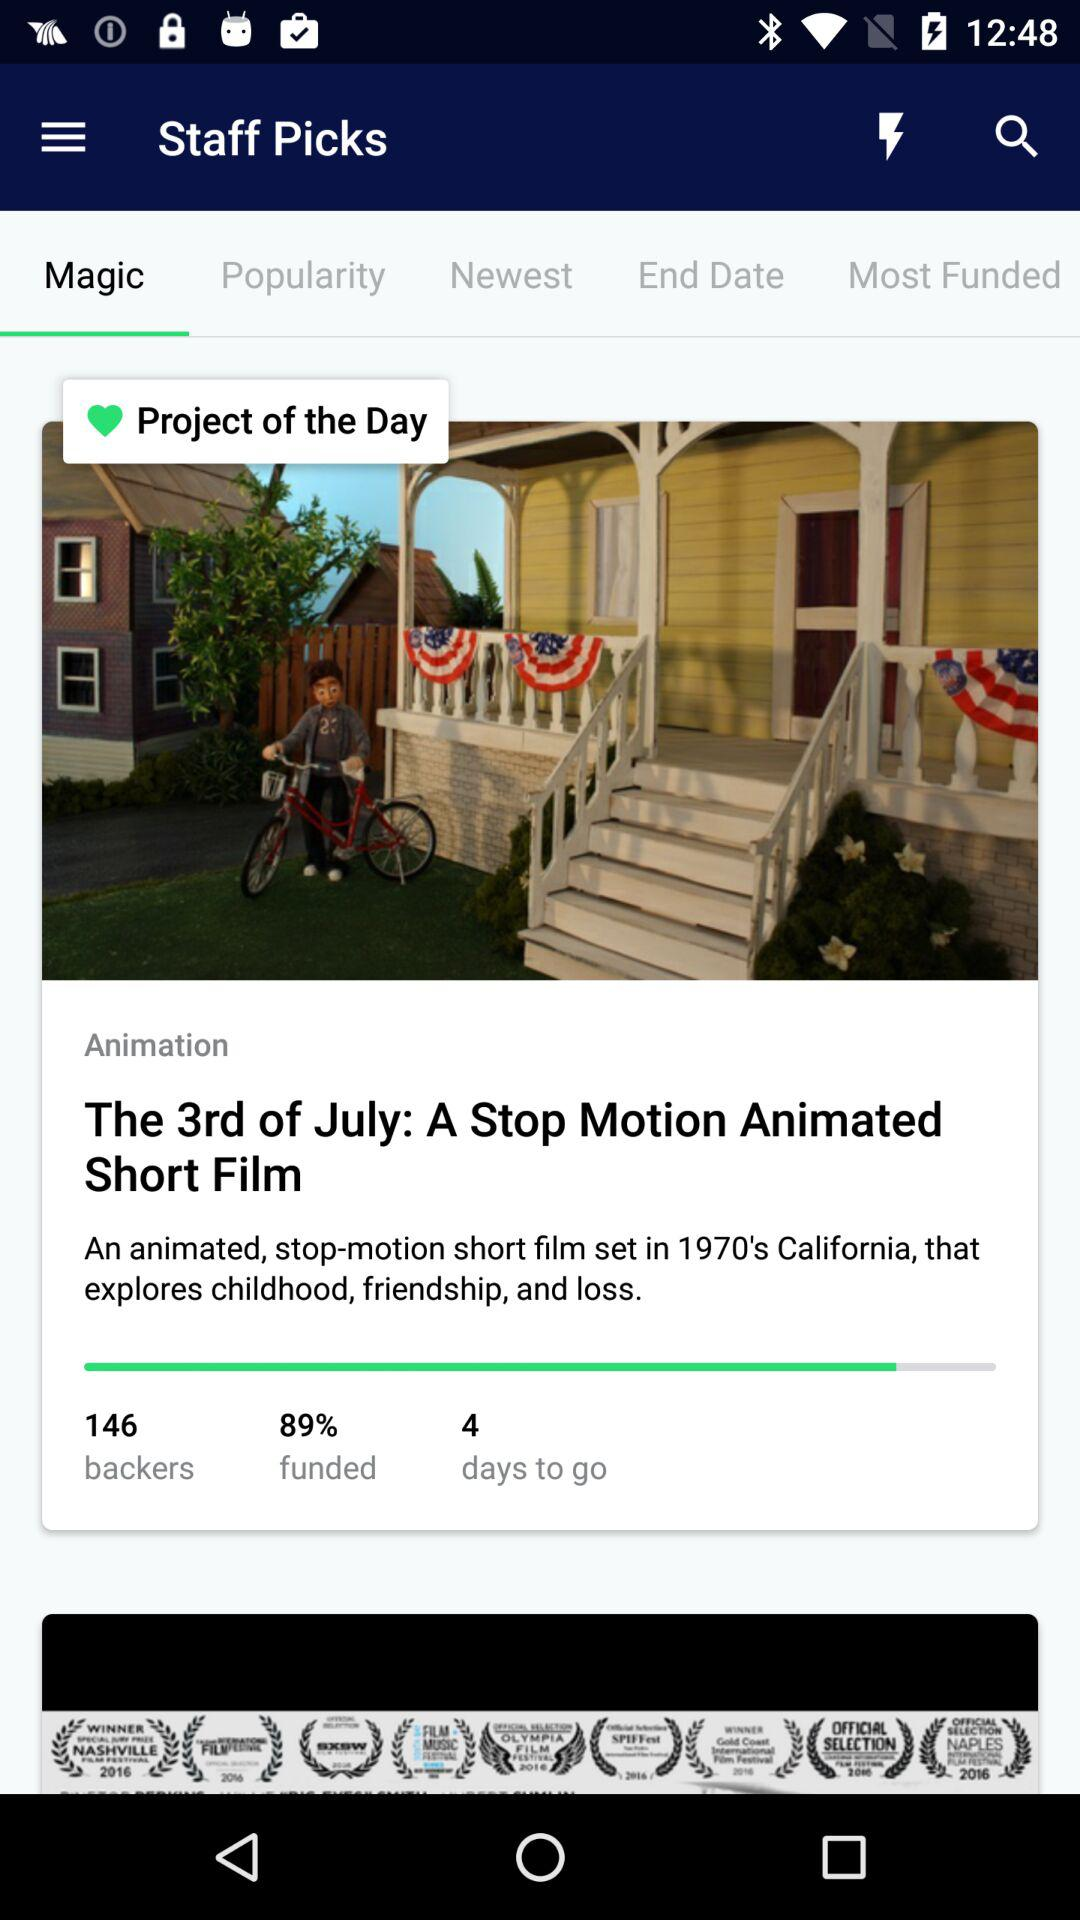What type of movie is this? The type of movie is a stop-motion animated short film. 